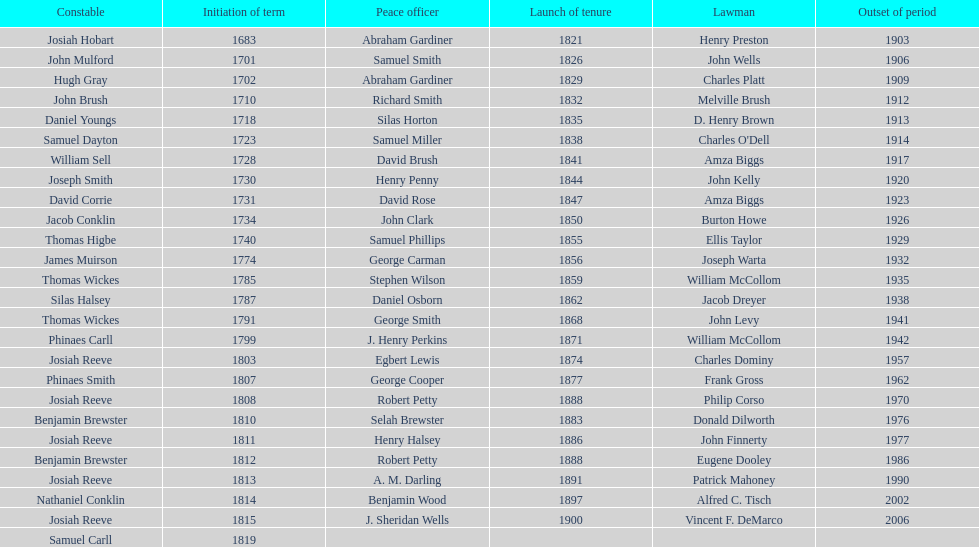During what period did benjamin brewster serve his second term? 1812. 